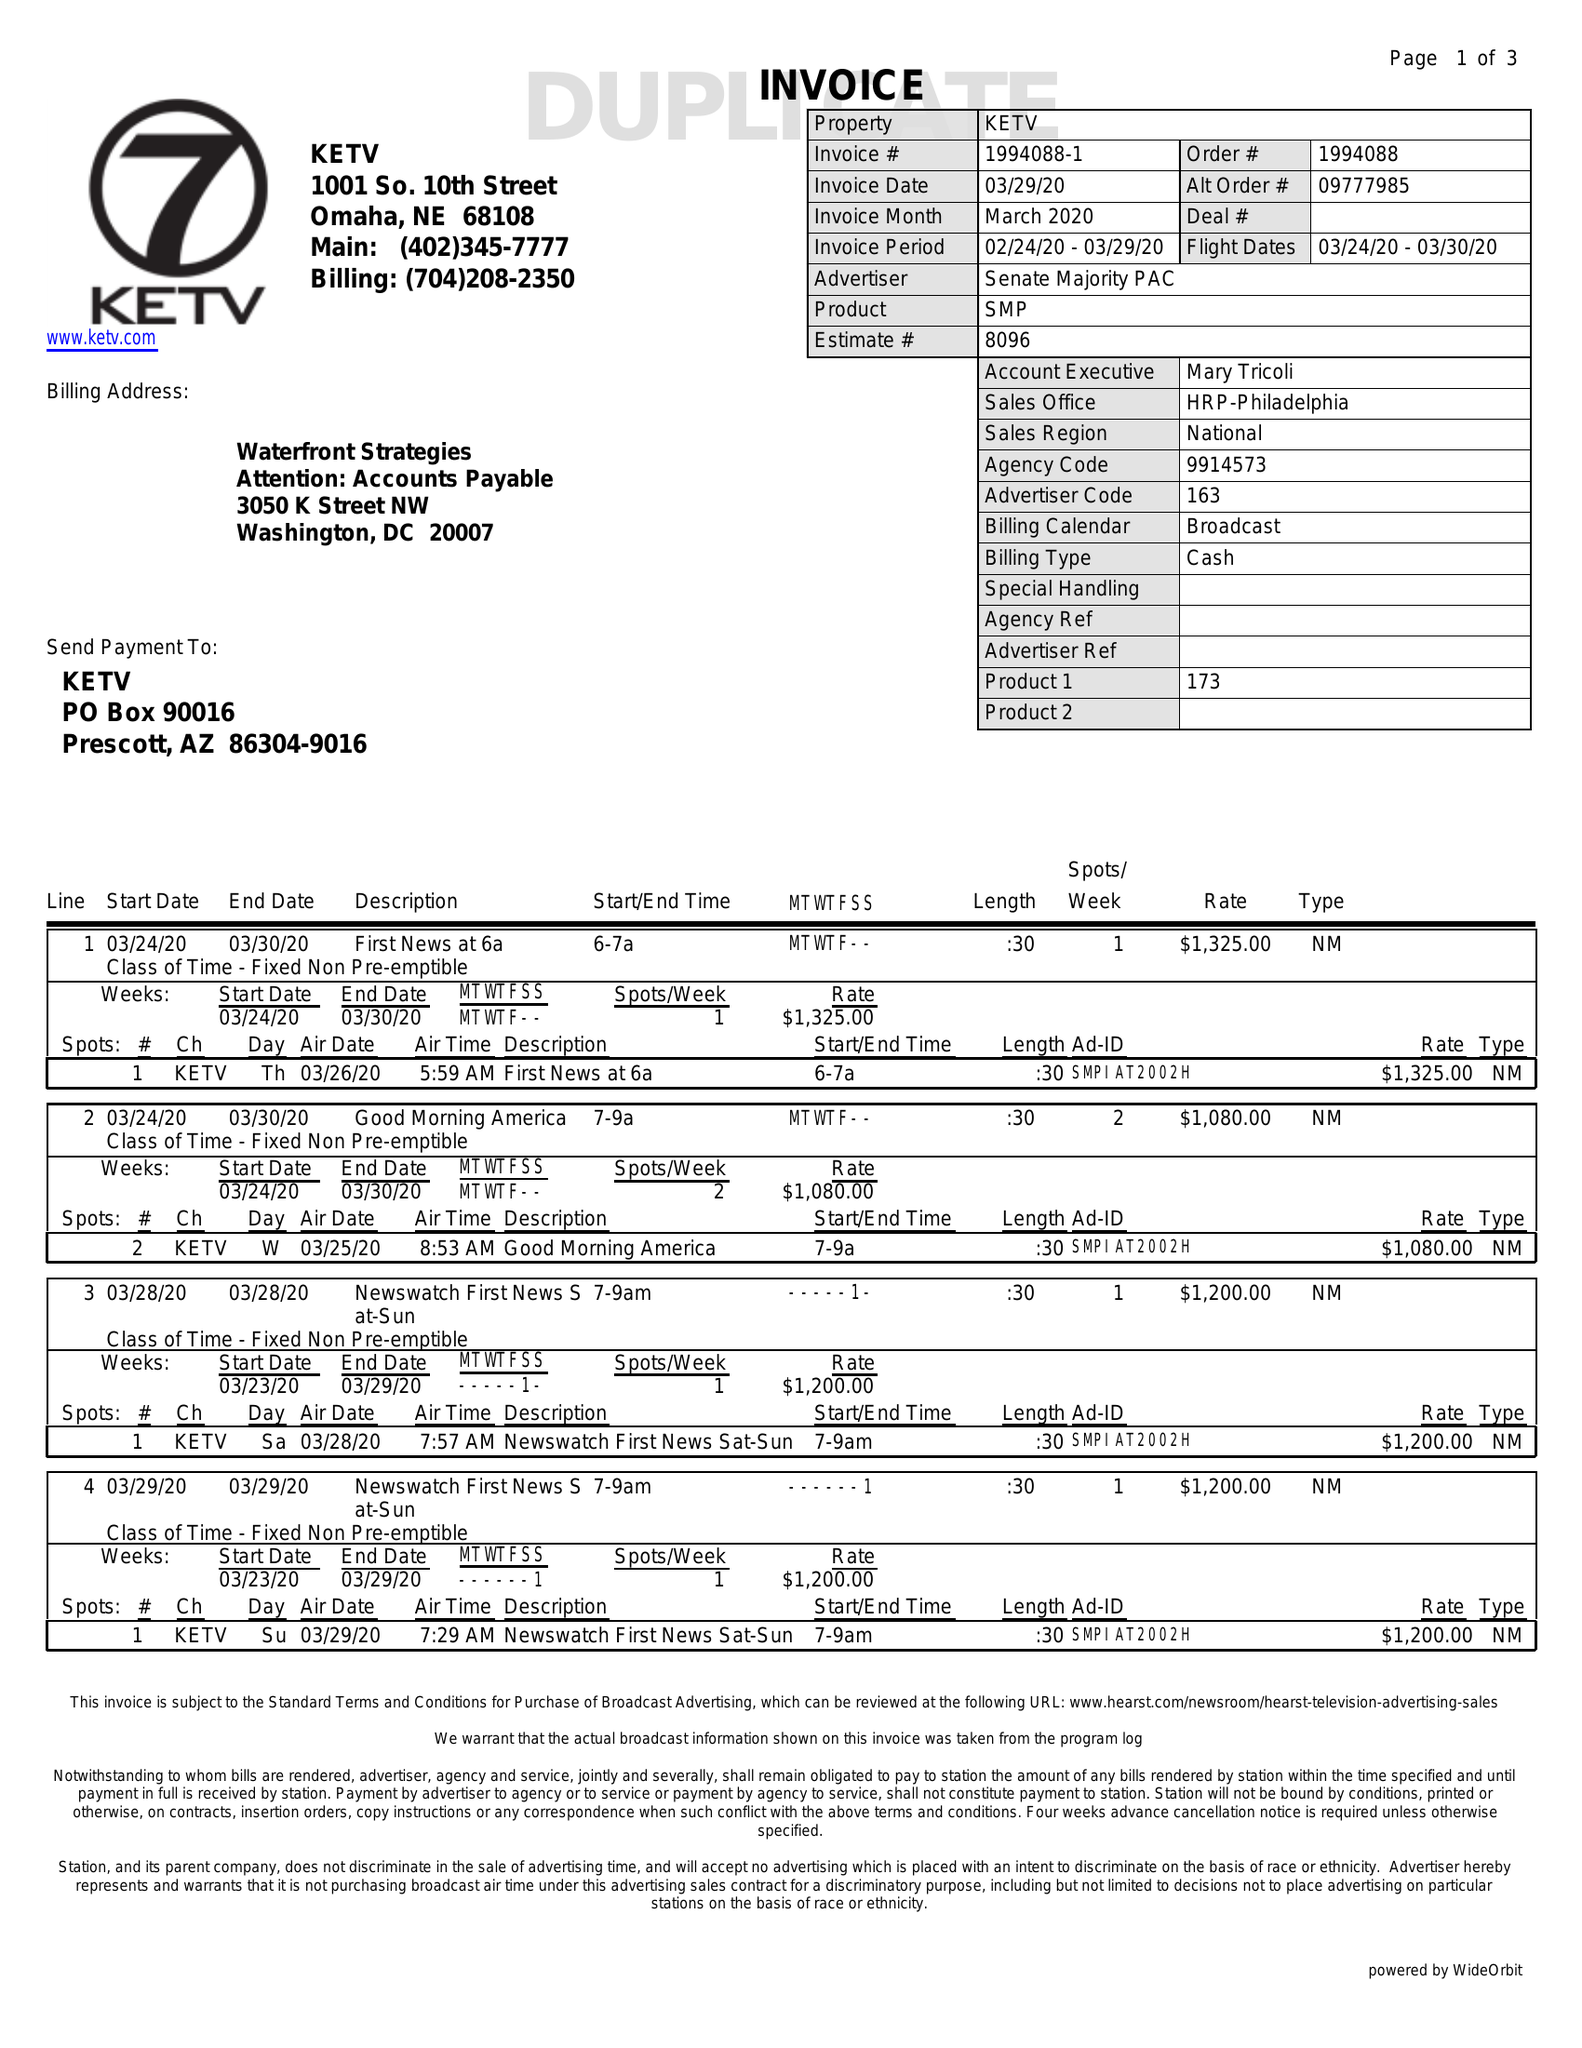What is the value for the advertiser?
Answer the question using a single word or phrase. SENATE MAJORITY PAC 